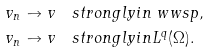Convert formula to latex. <formula><loc_0><loc_0><loc_500><loc_500>v _ { n } \to v & \quad s t r o n g l y i n \ w w s p , \\ v _ { n } \to v & \quad s t r o n g l y i n L ^ { q } ( \Omega ) .</formula> 